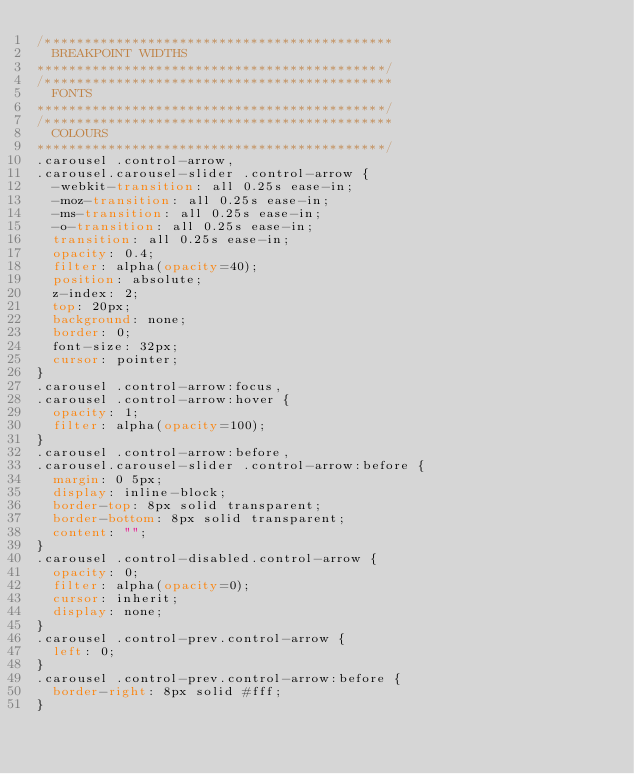<code> <loc_0><loc_0><loc_500><loc_500><_CSS_>/********************************************
	BREAKPOINT WIDTHS
********************************************/
/********************************************
	FONTS
********************************************/
/********************************************
	COLOURS
********************************************/
.carousel .control-arrow,
.carousel.carousel-slider .control-arrow {
  -webkit-transition: all 0.25s ease-in;
  -moz-transition: all 0.25s ease-in;
  -ms-transition: all 0.25s ease-in;
  -o-transition: all 0.25s ease-in;
  transition: all 0.25s ease-in;
  opacity: 0.4;
  filter: alpha(opacity=40);
  position: absolute;
  z-index: 2;
  top: 20px;
  background: none;
  border: 0;
  font-size: 32px;
  cursor: pointer;
}
.carousel .control-arrow:focus,
.carousel .control-arrow:hover {
  opacity: 1;
  filter: alpha(opacity=100);
}
.carousel .control-arrow:before,
.carousel.carousel-slider .control-arrow:before {
  margin: 0 5px;
  display: inline-block;
  border-top: 8px solid transparent;
  border-bottom: 8px solid transparent;
  content: "";
}
.carousel .control-disabled.control-arrow {
  opacity: 0;
  filter: alpha(opacity=0);
  cursor: inherit;
  display: none;
}
.carousel .control-prev.control-arrow {
  left: 0;
}
.carousel .control-prev.control-arrow:before {
  border-right: 8px solid #fff;
}</code> 